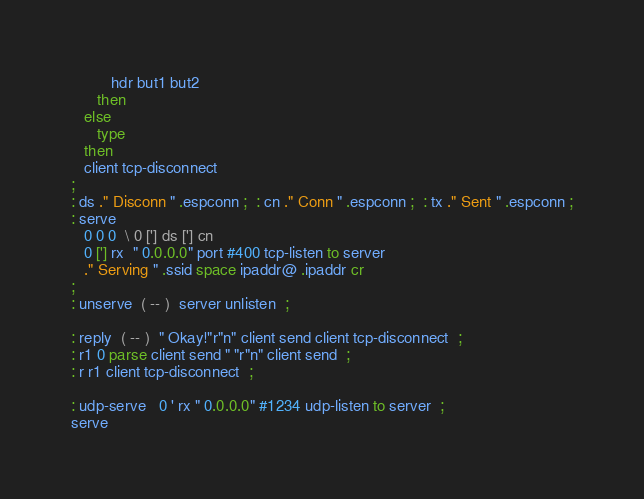Convert code to text. <code><loc_0><loc_0><loc_500><loc_500><_Forth_>         hdr but1 but2
      then
   else
      type
   then
   client tcp-disconnect
;
: ds ." Disconn " .espconn ;  : cn ." Conn " .espconn ;  : tx ." Sent " .espconn ;
: serve
   0 0 0  \ 0 ['] ds ['] cn
   0 ['] rx  " 0.0.0.0" port #400 tcp-listen to server
   ." Serving " .ssid space ipaddr@ .ipaddr cr
;
: unserve  ( -- )  server unlisten  ;

: reply  ( -- )  " Okay!"r"n" client send client tcp-disconnect  ;
: r1 0 parse client send " "r"n" client send  ;
: r r1 client tcp-disconnect  ;

: udp-serve   0 ' rx " 0.0.0.0" #1234 udp-listen to server  ;
serve
</code> 